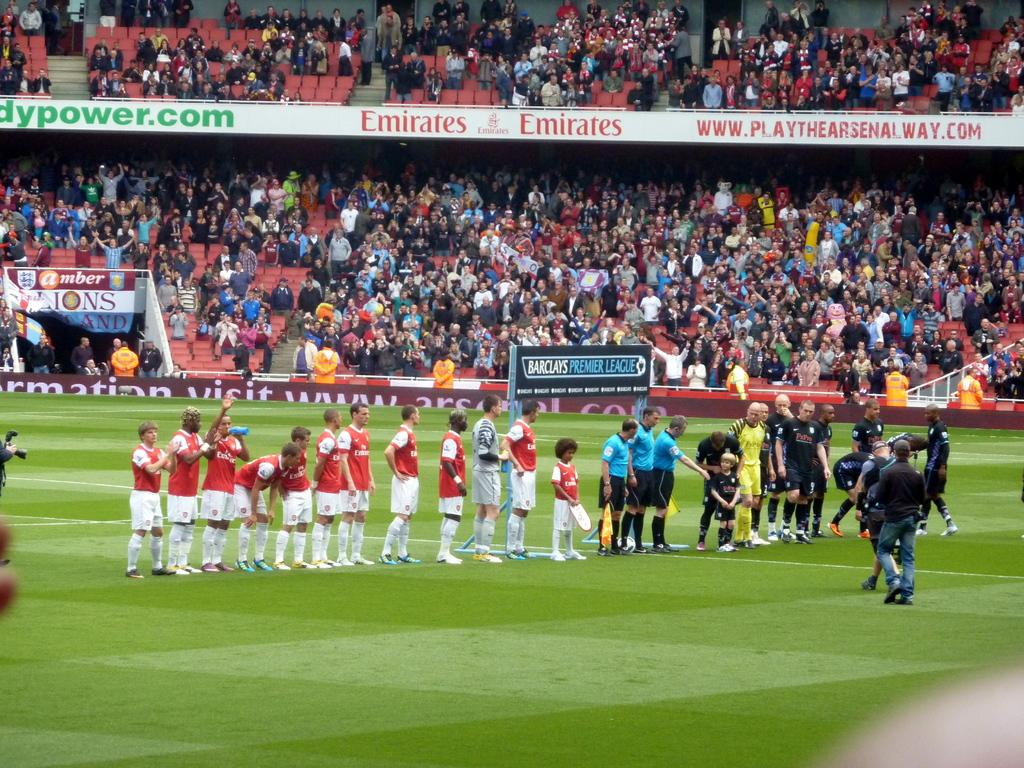Provide a one-sentence caption for the provided image. Two teams of young athletes gather on the field representing Barclays premier league and the stadium is packed. 